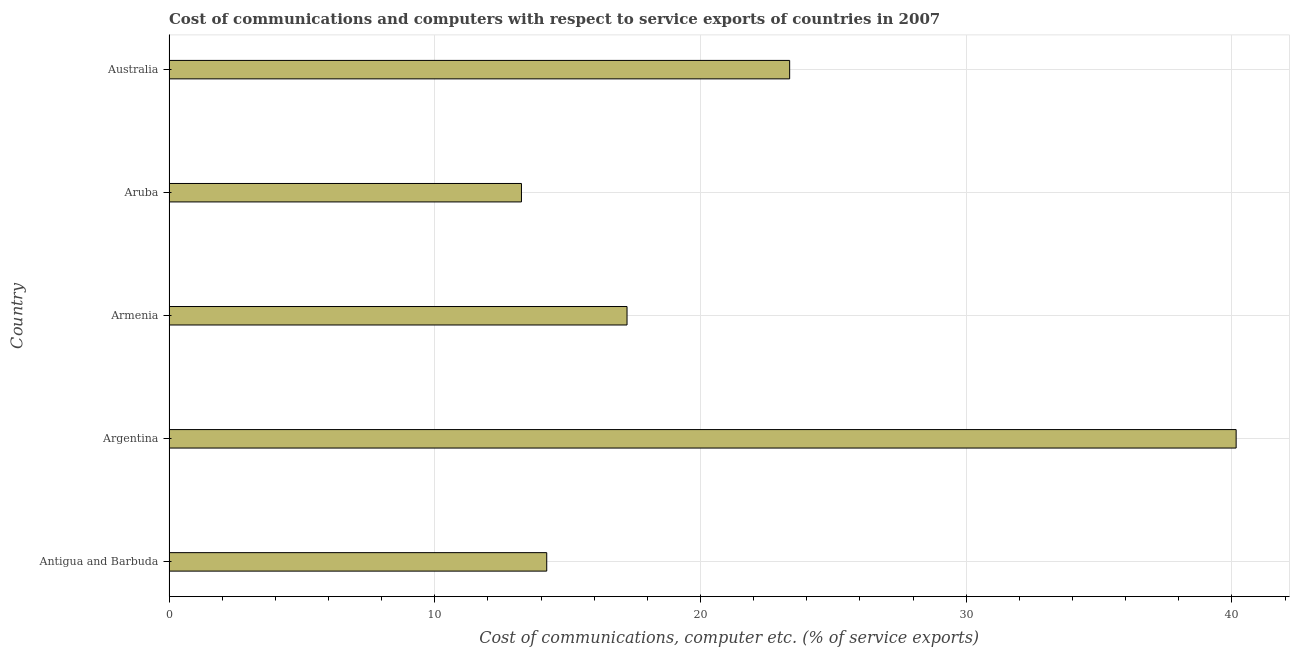Does the graph contain grids?
Keep it short and to the point. Yes. What is the title of the graph?
Ensure brevity in your answer.  Cost of communications and computers with respect to service exports of countries in 2007. What is the label or title of the X-axis?
Offer a very short reply. Cost of communications, computer etc. (% of service exports). What is the label or title of the Y-axis?
Ensure brevity in your answer.  Country. What is the cost of communications and computer in Aruba?
Offer a very short reply. 13.26. Across all countries, what is the maximum cost of communications and computer?
Provide a short and direct response. 40.16. Across all countries, what is the minimum cost of communications and computer?
Your response must be concise. 13.26. In which country was the cost of communications and computer maximum?
Your response must be concise. Argentina. In which country was the cost of communications and computer minimum?
Your answer should be very brief. Aruba. What is the sum of the cost of communications and computer?
Keep it short and to the point. 108.23. What is the difference between the cost of communications and computer in Argentina and Australia?
Ensure brevity in your answer.  16.8. What is the average cost of communications and computer per country?
Your response must be concise. 21.65. What is the median cost of communications and computer?
Keep it short and to the point. 17.24. What is the ratio of the cost of communications and computer in Antigua and Barbuda to that in Australia?
Your answer should be very brief. 0.61. Is the cost of communications and computer in Argentina less than that in Armenia?
Your response must be concise. No. Is the difference between the cost of communications and computer in Aruba and Australia greater than the difference between any two countries?
Offer a terse response. No. What is the difference between the highest and the second highest cost of communications and computer?
Provide a short and direct response. 16.8. What is the difference between the highest and the lowest cost of communications and computer?
Your answer should be compact. 26.89. In how many countries, is the cost of communications and computer greater than the average cost of communications and computer taken over all countries?
Give a very brief answer. 2. What is the difference between two consecutive major ticks on the X-axis?
Give a very brief answer. 10. Are the values on the major ticks of X-axis written in scientific E-notation?
Your answer should be compact. No. What is the Cost of communications, computer etc. (% of service exports) of Antigua and Barbuda?
Ensure brevity in your answer.  14.22. What is the Cost of communications, computer etc. (% of service exports) of Argentina?
Your answer should be very brief. 40.16. What is the Cost of communications, computer etc. (% of service exports) in Armenia?
Provide a succinct answer. 17.24. What is the Cost of communications, computer etc. (% of service exports) in Aruba?
Provide a short and direct response. 13.26. What is the Cost of communications, computer etc. (% of service exports) in Australia?
Your answer should be very brief. 23.36. What is the difference between the Cost of communications, computer etc. (% of service exports) in Antigua and Barbuda and Argentina?
Make the answer very short. -25.94. What is the difference between the Cost of communications, computer etc. (% of service exports) in Antigua and Barbuda and Armenia?
Ensure brevity in your answer.  -3.02. What is the difference between the Cost of communications, computer etc. (% of service exports) in Antigua and Barbuda and Aruba?
Offer a terse response. 0.95. What is the difference between the Cost of communications, computer etc. (% of service exports) in Antigua and Barbuda and Australia?
Your response must be concise. -9.14. What is the difference between the Cost of communications, computer etc. (% of service exports) in Argentina and Armenia?
Give a very brief answer. 22.92. What is the difference between the Cost of communications, computer etc. (% of service exports) in Argentina and Aruba?
Your answer should be very brief. 26.89. What is the difference between the Cost of communications, computer etc. (% of service exports) in Argentina and Australia?
Offer a very short reply. 16.8. What is the difference between the Cost of communications, computer etc. (% of service exports) in Armenia and Aruba?
Ensure brevity in your answer.  3.97. What is the difference between the Cost of communications, computer etc. (% of service exports) in Armenia and Australia?
Ensure brevity in your answer.  -6.12. What is the difference between the Cost of communications, computer etc. (% of service exports) in Aruba and Australia?
Offer a terse response. -10.09. What is the ratio of the Cost of communications, computer etc. (% of service exports) in Antigua and Barbuda to that in Argentina?
Offer a terse response. 0.35. What is the ratio of the Cost of communications, computer etc. (% of service exports) in Antigua and Barbuda to that in Armenia?
Give a very brief answer. 0.82. What is the ratio of the Cost of communications, computer etc. (% of service exports) in Antigua and Barbuda to that in Aruba?
Your answer should be compact. 1.07. What is the ratio of the Cost of communications, computer etc. (% of service exports) in Antigua and Barbuda to that in Australia?
Your answer should be very brief. 0.61. What is the ratio of the Cost of communications, computer etc. (% of service exports) in Argentina to that in Armenia?
Give a very brief answer. 2.33. What is the ratio of the Cost of communications, computer etc. (% of service exports) in Argentina to that in Aruba?
Keep it short and to the point. 3.03. What is the ratio of the Cost of communications, computer etc. (% of service exports) in Argentina to that in Australia?
Offer a terse response. 1.72. What is the ratio of the Cost of communications, computer etc. (% of service exports) in Armenia to that in Australia?
Provide a succinct answer. 0.74. What is the ratio of the Cost of communications, computer etc. (% of service exports) in Aruba to that in Australia?
Make the answer very short. 0.57. 